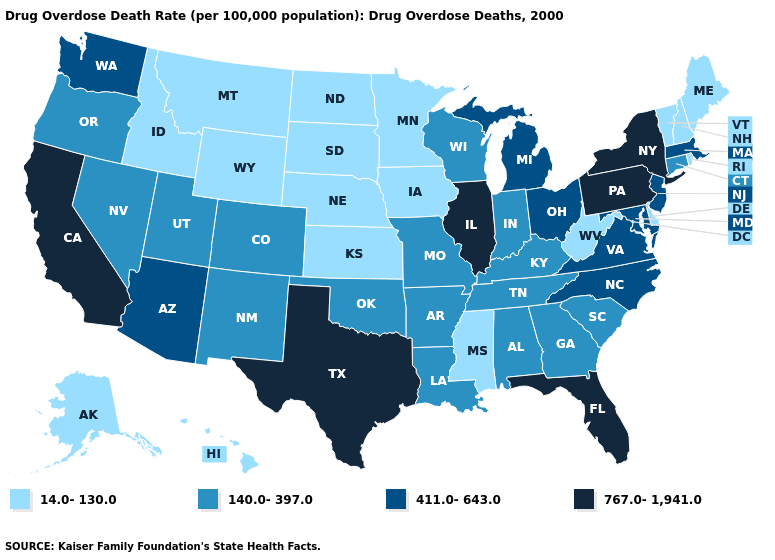What is the highest value in states that border Connecticut?
Answer briefly. 767.0-1,941.0. Among the states that border Georgia , which have the highest value?
Answer briefly. Florida. Among the states that border Wyoming , does Colorado have the lowest value?
Give a very brief answer. No. Does Alaska have a lower value than Virginia?
Concise answer only. Yes. Does New York have the lowest value in the Northeast?
Short answer required. No. Is the legend a continuous bar?
Give a very brief answer. No. Is the legend a continuous bar?
Short answer required. No. Which states hav the highest value in the Northeast?
Give a very brief answer. New York, Pennsylvania. What is the value of Ohio?
Be succinct. 411.0-643.0. Does Connecticut have the highest value in the Northeast?
Give a very brief answer. No. Name the states that have a value in the range 767.0-1,941.0?
Short answer required. California, Florida, Illinois, New York, Pennsylvania, Texas. Does Montana have the same value as Utah?
Answer briefly. No. What is the lowest value in the USA?
Keep it brief. 14.0-130.0. What is the value of Washington?
Write a very short answer. 411.0-643.0. What is the value of Rhode Island?
Concise answer only. 14.0-130.0. 